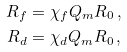<formula> <loc_0><loc_0><loc_500><loc_500>R _ { f } & = \chi _ { f } Q _ { m } R _ { 0 } \, , \\ R _ { d } & = \chi _ { d } Q _ { m } R _ { 0 } \, ,</formula> 